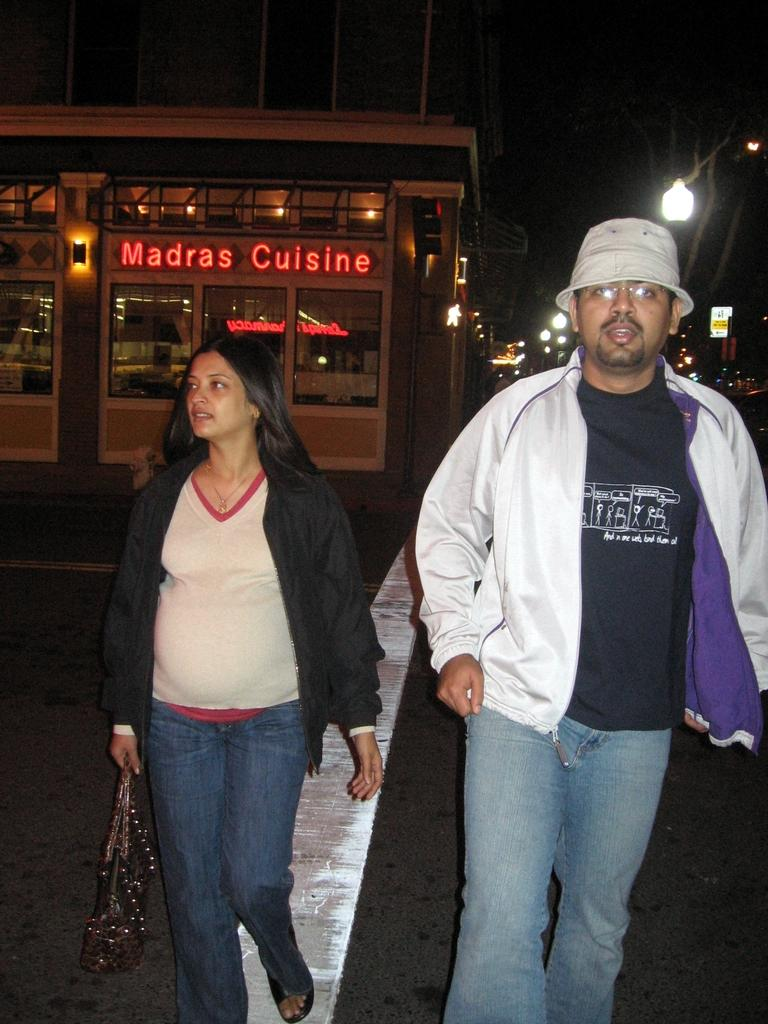What are the two people in the image doing? The two people in the image are walking. Can you describe what one of the people is carrying? One of the people is holding a bag. What can be seen in the distance behind the people? There is a building and lights visible in the background. What type of stitch is being used to sew the flowers on the person's clothing in the image? There are no flowers or clothing mentioned in the image, so it is not possible to determine the type of stitch being used. 